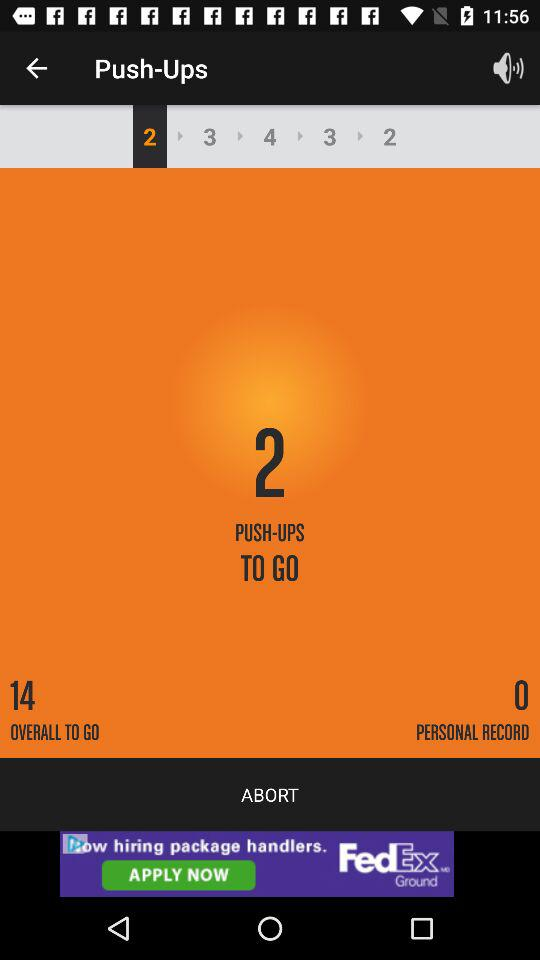How many push ups are left in the set?
Answer the question using a single word or phrase. 2 